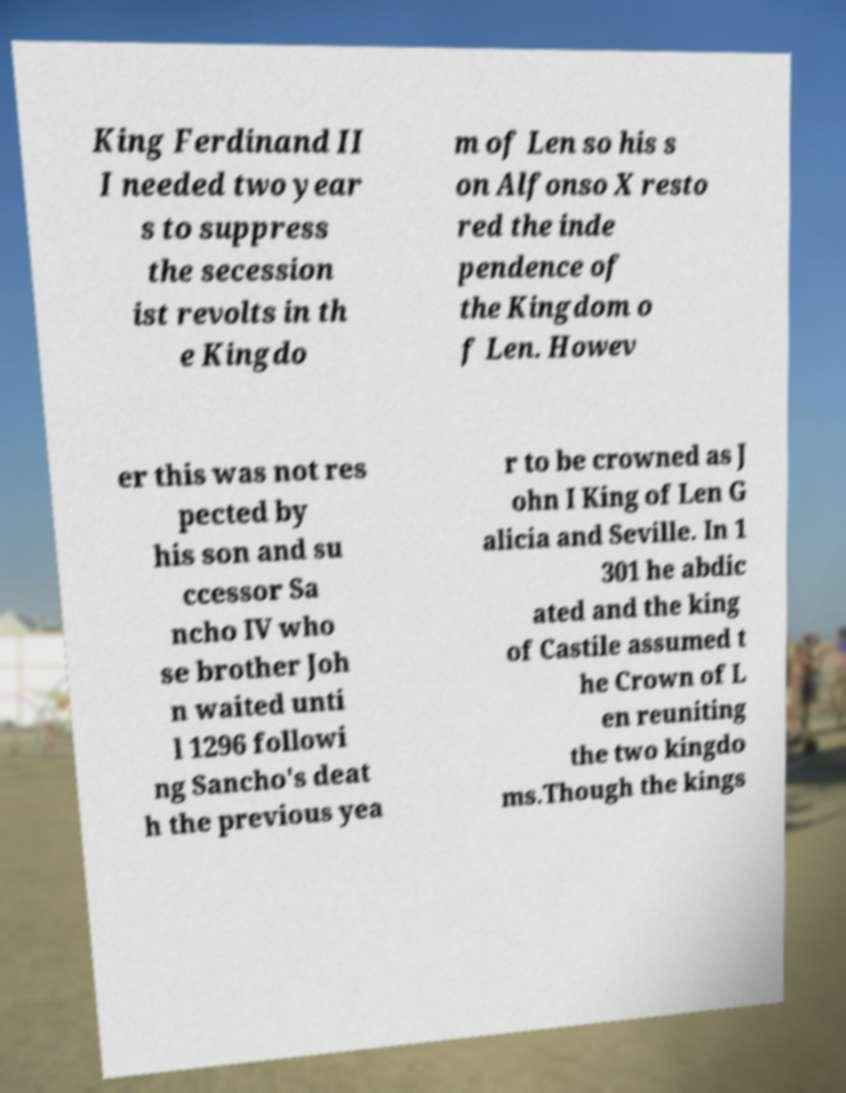Please read and relay the text visible in this image. What does it say? King Ferdinand II I needed two year s to suppress the secession ist revolts in th e Kingdo m of Len so his s on Alfonso X resto red the inde pendence of the Kingdom o f Len. Howev er this was not res pected by his son and su ccessor Sa ncho IV who se brother Joh n waited unti l 1296 followi ng Sancho's deat h the previous yea r to be crowned as J ohn I King of Len G alicia and Seville. In 1 301 he abdic ated and the king of Castile assumed t he Crown of L en reuniting the two kingdo ms.Though the kings 